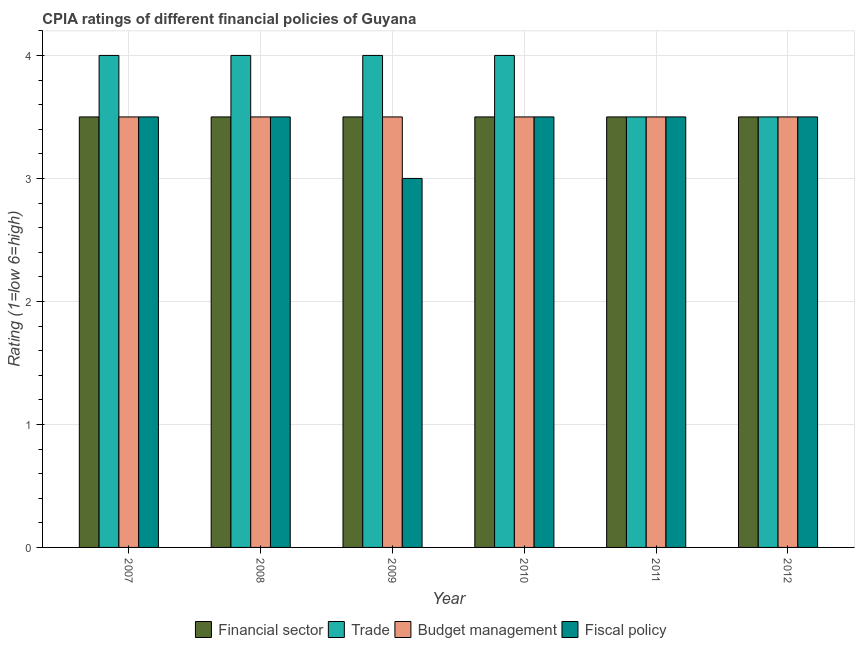How many different coloured bars are there?
Make the answer very short. 4. In how many cases, is the number of bars for a given year not equal to the number of legend labels?
Offer a very short reply. 0. What is the cpia rating of budget management in 2012?
Your response must be concise. 3.5. Across all years, what is the maximum cpia rating of budget management?
Provide a short and direct response. 3.5. In which year was the cpia rating of fiscal policy maximum?
Provide a short and direct response. 2007. In which year was the cpia rating of financial sector minimum?
Your response must be concise. 2007. What is the total cpia rating of financial sector in the graph?
Your answer should be compact. 21. What is the difference between the cpia rating of financial sector in 2008 and that in 2012?
Offer a very short reply. 0. What is the difference between the cpia rating of fiscal policy in 2012 and the cpia rating of budget management in 2007?
Provide a short and direct response. 0. In the year 2010, what is the difference between the cpia rating of fiscal policy and cpia rating of trade?
Keep it short and to the point. 0. In how many years, is the cpia rating of fiscal policy greater than 3.4?
Give a very brief answer. 5. Is the cpia rating of financial sector in 2010 less than that in 2011?
Make the answer very short. No. What is the difference between the highest and the second highest cpia rating of trade?
Make the answer very short. 0. What is the difference between the highest and the lowest cpia rating of trade?
Your answer should be very brief. 0.5. In how many years, is the cpia rating of trade greater than the average cpia rating of trade taken over all years?
Give a very brief answer. 4. What does the 4th bar from the left in 2012 represents?
Ensure brevity in your answer.  Fiscal policy. What does the 1st bar from the right in 2009 represents?
Offer a very short reply. Fiscal policy. Are all the bars in the graph horizontal?
Offer a very short reply. No. How many years are there in the graph?
Provide a short and direct response. 6. What is the difference between two consecutive major ticks on the Y-axis?
Keep it short and to the point. 1. Are the values on the major ticks of Y-axis written in scientific E-notation?
Your answer should be very brief. No. How are the legend labels stacked?
Keep it short and to the point. Horizontal. What is the title of the graph?
Offer a terse response. CPIA ratings of different financial policies of Guyana. What is the Rating (1=low 6=high) of Financial sector in 2007?
Give a very brief answer. 3.5. What is the Rating (1=low 6=high) of Budget management in 2007?
Give a very brief answer. 3.5. What is the Rating (1=low 6=high) in Fiscal policy in 2007?
Keep it short and to the point. 3.5. What is the Rating (1=low 6=high) of Financial sector in 2008?
Provide a short and direct response. 3.5. What is the Rating (1=low 6=high) of Trade in 2009?
Keep it short and to the point. 4. What is the Rating (1=low 6=high) in Budget management in 2009?
Your response must be concise. 3.5. What is the Rating (1=low 6=high) in Financial sector in 2010?
Offer a very short reply. 3.5. What is the Rating (1=low 6=high) of Trade in 2011?
Provide a succinct answer. 3.5. What is the Rating (1=low 6=high) in Fiscal policy in 2011?
Your response must be concise. 3.5. What is the Rating (1=low 6=high) in Trade in 2012?
Make the answer very short. 3.5. What is the Rating (1=low 6=high) of Fiscal policy in 2012?
Provide a succinct answer. 3.5. Across all years, what is the maximum Rating (1=low 6=high) of Financial sector?
Your response must be concise. 3.5. Across all years, what is the maximum Rating (1=low 6=high) of Trade?
Your answer should be compact. 4. Across all years, what is the maximum Rating (1=low 6=high) of Budget management?
Make the answer very short. 3.5. Across all years, what is the maximum Rating (1=low 6=high) of Fiscal policy?
Your answer should be very brief. 3.5. Across all years, what is the minimum Rating (1=low 6=high) of Financial sector?
Provide a succinct answer. 3.5. Across all years, what is the minimum Rating (1=low 6=high) in Budget management?
Your response must be concise. 3.5. Across all years, what is the minimum Rating (1=low 6=high) of Fiscal policy?
Offer a terse response. 3. What is the total Rating (1=low 6=high) of Financial sector in the graph?
Make the answer very short. 21. What is the total Rating (1=low 6=high) of Trade in the graph?
Offer a terse response. 23. What is the total Rating (1=low 6=high) of Budget management in the graph?
Provide a short and direct response. 21. What is the total Rating (1=low 6=high) in Fiscal policy in the graph?
Offer a very short reply. 20.5. What is the difference between the Rating (1=low 6=high) in Trade in 2007 and that in 2008?
Offer a terse response. 0. What is the difference between the Rating (1=low 6=high) in Fiscal policy in 2007 and that in 2009?
Your answer should be very brief. 0.5. What is the difference between the Rating (1=low 6=high) of Financial sector in 2007 and that in 2010?
Provide a succinct answer. 0. What is the difference between the Rating (1=low 6=high) of Financial sector in 2007 and that in 2011?
Ensure brevity in your answer.  0. What is the difference between the Rating (1=low 6=high) in Fiscal policy in 2007 and that in 2011?
Provide a short and direct response. 0. What is the difference between the Rating (1=low 6=high) in Financial sector in 2007 and that in 2012?
Your answer should be very brief. 0. What is the difference between the Rating (1=low 6=high) in Budget management in 2007 and that in 2012?
Provide a short and direct response. 0. What is the difference between the Rating (1=low 6=high) of Fiscal policy in 2007 and that in 2012?
Your answer should be compact. 0. What is the difference between the Rating (1=low 6=high) in Financial sector in 2008 and that in 2009?
Your response must be concise. 0. What is the difference between the Rating (1=low 6=high) in Budget management in 2008 and that in 2009?
Ensure brevity in your answer.  0. What is the difference between the Rating (1=low 6=high) in Financial sector in 2008 and that in 2010?
Offer a terse response. 0. What is the difference between the Rating (1=low 6=high) of Budget management in 2008 and that in 2010?
Your response must be concise. 0. What is the difference between the Rating (1=low 6=high) in Fiscal policy in 2008 and that in 2010?
Ensure brevity in your answer.  0. What is the difference between the Rating (1=low 6=high) in Financial sector in 2008 and that in 2011?
Your answer should be very brief. 0. What is the difference between the Rating (1=low 6=high) in Trade in 2008 and that in 2011?
Keep it short and to the point. 0.5. What is the difference between the Rating (1=low 6=high) of Financial sector in 2008 and that in 2012?
Your answer should be very brief. 0. What is the difference between the Rating (1=low 6=high) of Trade in 2008 and that in 2012?
Make the answer very short. 0.5. What is the difference between the Rating (1=low 6=high) of Fiscal policy in 2008 and that in 2012?
Offer a very short reply. 0. What is the difference between the Rating (1=low 6=high) of Trade in 2009 and that in 2010?
Offer a terse response. 0. What is the difference between the Rating (1=low 6=high) in Budget management in 2009 and that in 2010?
Make the answer very short. 0. What is the difference between the Rating (1=low 6=high) of Financial sector in 2009 and that in 2011?
Make the answer very short. 0. What is the difference between the Rating (1=low 6=high) of Trade in 2009 and that in 2011?
Give a very brief answer. 0.5. What is the difference between the Rating (1=low 6=high) of Budget management in 2009 and that in 2011?
Offer a very short reply. 0. What is the difference between the Rating (1=low 6=high) in Financial sector in 2009 and that in 2012?
Provide a succinct answer. 0. What is the difference between the Rating (1=low 6=high) in Budget management in 2010 and that in 2011?
Keep it short and to the point. 0. What is the difference between the Rating (1=low 6=high) in Fiscal policy in 2010 and that in 2011?
Give a very brief answer. 0. What is the difference between the Rating (1=low 6=high) of Budget management in 2010 and that in 2012?
Your answer should be compact. 0. What is the difference between the Rating (1=low 6=high) in Fiscal policy in 2010 and that in 2012?
Your answer should be compact. 0. What is the difference between the Rating (1=low 6=high) in Financial sector in 2011 and that in 2012?
Make the answer very short. 0. What is the difference between the Rating (1=low 6=high) of Budget management in 2011 and that in 2012?
Give a very brief answer. 0. What is the difference between the Rating (1=low 6=high) of Fiscal policy in 2011 and that in 2012?
Your answer should be very brief. 0. What is the difference between the Rating (1=low 6=high) of Financial sector in 2007 and the Rating (1=low 6=high) of Fiscal policy in 2008?
Offer a very short reply. 0. What is the difference between the Rating (1=low 6=high) of Trade in 2007 and the Rating (1=low 6=high) of Budget management in 2008?
Keep it short and to the point. 0.5. What is the difference between the Rating (1=low 6=high) in Trade in 2007 and the Rating (1=low 6=high) in Fiscal policy in 2008?
Offer a very short reply. 0.5. What is the difference between the Rating (1=low 6=high) in Budget management in 2007 and the Rating (1=low 6=high) in Fiscal policy in 2008?
Provide a short and direct response. 0. What is the difference between the Rating (1=low 6=high) in Trade in 2007 and the Rating (1=low 6=high) in Budget management in 2009?
Offer a terse response. 0.5. What is the difference between the Rating (1=low 6=high) in Financial sector in 2007 and the Rating (1=low 6=high) in Trade in 2010?
Provide a short and direct response. -0.5. What is the difference between the Rating (1=low 6=high) of Financial sector in 2007 and the Rating (1=low 6=high) of Budget management in 2010?
Ensure brevity in your answer.  0. What is the difference between the Rating (1=low 6=high) of Financial sector in 2007 and the Rating (1=low 6=high) of Fiscal policy in 2010?
Your answer should be very brief. 0. What is the difference between the Rating (1=low 6=high) of Trade in 2007 and the Rating (1=low 6=high) of Fiscal policy in 2010?
Your response must be concise. 0.5. What is the difference between the Rating (1=low 6=high) in Budget management in 2007 and the Rating (1=low 6=high) in Fiscal policy in 2010?
Make the answer very short. 0. What is the difference between the Rating (1=low 6=high) of Financial sector in 2007 and the Rating (1=low 6=high) of Fiscal policy in 2011?
Make the answer very short. 0. What is the difference between the Rating (1=low 6=high) in Trade in 2007 and the Rating (1=low 6=high) in Budget management in 2011?
Offer a very short reply. 0.5. What is the difference between the Rating (1=low 6=high) in Trade in 2007 and the Rating (1=low 6=high) in Fiscal policy in 2011?
Offer a very short reply. 0.5. What is the difference between the Rating (1=low 6=high) in Budget management in 2007 and the Rating (1=low 6=high) in Fiscal policy in 2011?
Your answer should be compact. 0. What is the difference between the Rating (1=low 6=high) of Trade in 2007 and the Rating (1=low 6=high) of Budget management in 2012?
Provide a short and direct response. 0.5. What is the difference between the Rating (1=low 6=high) in Trade in 2007 and the Rating (1=low 6=high) in Fiscal policy in 2012?
Your answer should be compact. 0.5. What is the difference between the Rating (1=low 6=high) of Budget management in 2007 and the Rating (1=low 6=high) of Fiscal policy in 2012?
Your response must be concise. 0. What is the difference between the Rating (1=low 6=high) of Financial sector in 2008 and the Rating (1=low 6=high) of Budget management in 2009?
Provide a short and direct response. 0. What is the difference between the Rating (1=low 6=high) of Financial sector in 2008 and the Rating (1=low 6=high) of Trade in 2010?
Ensure brevity in your answer.  -0.5. What is the difference between the Rating (1=low 6=high) of Financial sector in 2008 and the Rating (1=low 6=high) of Budget management in 2010?
Your answer should be very brief. 0. What is the difference between the Rating (1=low 6=high) in Financial sector in 2008 and the Rating (1=low 6=high) in Fiscal policy in 2010?
Provide a short and direct response. 0. What is the difference between the Rating (1=low 6=high) in Trade in 2008 and the Rating (1=low 6=high) in Budget management in 2010?
Your response must be concise. 0.5. What is the difference between the Rating (1=low 6=high) in Financial sector in 2008 and the Rating (1=low 6=high) in Fiscal policy in 2011?
Your answer should be compact. 0. What is the difference between the Rating (1=low 6=high) of Financial sector in 2008 and the Rating (1=low 6=high) of Trade in 2012?
Your answer should be very brief. 0. What is the difference between the Rating (1=low 6=high) of Trade in 2008 and the Rating (1=low 6=high) of Budget management in 2012?
Offer a very short reply. 0.5. What is the difference between the Rating (1=low 6=high) of Budget management in 2008 and the Rating (1=low 6=high) of Fiscal policy in 2012?
Provide a short and direct response. 0. What is the difference between the Rating (1=low 6=high) of Financial sector in 2009 and the Rating (1=low 6=high) of Budget management in 2010?
Your answer should be very brief. 0. What is the difference between the Rating (1=low 6=high) in Financial sector in 2009 and the Rating (1=low 6=high) in Fiscal policy in 2010?
Offer a very short reply. 0. What is the difference between the Rating (1=low 6=high) in Trade in 2009 and the Rating (1=low 6=high) in Budget management in 2010?
Offer a very short reply. 0.5. What is the difference between the Rating (1=low 6=high) of Financial sector in 2009 and the Rating (1=low 6=high) of Trade in 2011?
Your answer should be compact. 0. What is the difference between the Rating (1=low 6=high) in Trade in 2009 and the Rating (1=low 6=high) in Fiscal policy in 2011?
Offer a very short reply. 0.5. What is the difference between the Rating (1=low 6=high) in Financial sector in 2009 and the Rating (1=low 6=high) in Trade in 2012?
Ensure brevity in your answer.  0. What is the difference between the Rating (1=low 6=high) of Financial sector in 2009 and the Rating (1=low 6=high) of Fiscal policy in 2012?
Offer a very short reply. 0. What is the difference between the Rating (1=low 6=high) of Trade in 2009 and the Rating (1=low 6=high) of Budget management in 2012?
Provide a short and direct response. 0.5. What is the difference between the Rating (1=low 6=high) of Trade in 2009 and the Rating (1=low 6=high) of Fiscal policy in 2012?
Offer a very short reply. 0.5. What is the difference between the Rating (1=low 6=high) in Budget management in 2009 and the Rating (1=low 6=high) in Fiscal policy in 2012?
Keep it short and to the point. 0. What is the difference between the Rating (1=low 6=high) of Financial sector in 2010 and the Rating (1=low 6=high) of Trade in 2011?
Give a very brief answer. 0. What is the difference between the Rating (1=low 6=high) in Trade in 2010 and the Rating (1=low 6=high) in Budget management in 2011?
Your answer should be compact. 0.5. What is the difference between the Rating (1=low 6=high) in Budget management in 2010 and the Rating (1=low 6=high) in Fiscal policy in 2011?
Keep it short and to the point. 0. What is the difference between the Rating (1=low 6=high) of Financial sector in 2010 and the Rating (1=low 6=high) of Trade in 2012?
Give a very brief answer. 0. What is the difference between the Rating (1=low 6=high) of Financial sector in 2010 and the Rating (1=low 6=high) of Fiscal policy in 2012?
Your answer should be compact. 0. What is the difference between the Rating (1=low 6=high) of Trade in 2010 and the Rating (1=low 6=high) of Budget management in 2012?
Make the answer very short. 0.5. What is the difference between the Rating (1=low 6=high) in Budget management in 2010 and the Rating (1=low 6=high) in Fiscal policy in 2012?
Your response must be concise. 0. What is the difference between the Rating (1=low 6=high) in Trade in 2011 and the Rating (1=low 6=high) in Fiscal policy in 2012?
Give a very brief answer. 0. What is the difference between the Rating (1=low 6=high) of Budget management in 2011 and the Rating (1=low 6=high) of Fiscal policy in 2012?
Make the answer very short. 0. What is the average Rating (1=low 6=high) of Trade per year?
Provide a succinct answer. 3.83. What is the average Rating (1=low 6=high) of Budget management per year?
Your answer should be compact. 3.5. What is the average Rating (1=low 6=high) of Fiscal policy per year?
Keep it short and to the point. 3.42. In the year 2007, what is the difference between the Rating (1=low 6=high) in Financial sector and Rating (1=low 6=high) in Budget management?
Your answer should be compact. 0. In the year 2007, what is the difference between the Rating (1=low 6=high) of Trade and Rating (1=low 6=high) of Budget management?
Give a very brief answer. 0.5. In the year 2007, what is the difference between the Rating (1=low 6=high) of Budget management and Rating (1=low 6=high) of Fiscal policy?
Keep it short and to the point. 0. In the year 2008, what is the difference between the Rating (1=low 6=high) in Financial sector and Rating (1=low 6=high) in Budget management?
Give a very brief answer. 0. In the year 2008, what is the difference between the Rating (1=low 6=high) of Budget management and Rating (1=low 6=high) of Fiscal policy?
Offer a very short reply. 0. In the year 2009, what is the difference between the Rating (1=low 6=high) in Trade and Rating (1=low 6=high) in Budget management?
Provide a succinct answer. 0.5. In the year 2009, what is the difference between the Rating (1=low 6=high) of Trade and Rating (1=low 6=high) of Fiscal policy?
Your answer should be compact. 1. In the year 2009, what is the difference between the Rating (1=low 6=high) of Budget management and Rating (1=low 6=high) of Fiscal policy?
Your answer should be very brief. 0.5. In the year 2010, what is the difference between the Rating (1=low 6=high) in Financial sector and Rating (1=low 6=high) in Trade?
Provide a succinct answer. -0.5. In the year 2010, what is the difference between the Rating (1=low 6=high) in Financial sector and Rating (1=low 6=high) in Budget management?
Provide a short and direct response. 0. In the year 2010, what is the difference between the Rating (1=low 6=high) in Trade and Rating (1=low 6=high) in Budget management?
Your response must be concise. 0.5. In the year 2011, what is the difference between the Rating (1=low 6=high) of Financial sector and Rating (1=low 6=high) of Trade?
Provide a succinct answer. 0. In the year 2011, what is the difference between the Rating (1=low 6=high) in Financial sector and Rating (1=low 6=high) in Budget management?
Your response must be concise. 0. In the year 2012, what is the difference between the Rating (1=low 6=high) in Financial sector and Rating (1=low 6=high) in Budget management?
Your answer should be very brief. 0. In the year 2012, what is the difference between the Rating (1=low 6=high) in Financial sector and Rating (1=low 6=high) in Fiscal policy?
Keep it short and to the point. 0. In the year 2012, what is the difference between the Rating (1=low 6=high) in Trade and Rating (1=low 6=high) in Fiscal policy?
Keep it short and to the point. 0. What is the ratio of the Rating (1=low 6=high) of Financial sector in 2007 to that in 2008?
Offer a very short reply. 1. What is the ratio of the Rating (1=low 6=high) in Trade in 2007 to that in 2008?
Offer a terse response. 1. What is the ratio of the Rating (1=low 6=high) in Budget management in 2007 to that in 2008?
Your answer should be compact. 1. What is the ratio of the Rating (1=low 6=high) in Budget management in 2007 to that in 2009?
Make the answer very short. 1. What is the ratio of the Rating (1=low 6=high) in Fiscal policy in 2007 to that in 2009?
Provide a succinct answer. 1.17. What is the ratio of the Rating (1=low 6=high) of Financial sector in 2007 to that in 2010?
Your response must be concise. 1. What is the ratio of the Rating (1=low 6=high) of Fiscal policy in 2007 to that in 2010?
Offer a terse response. 1. What is the ratio of the Rating (1=low 6=high) of Financial sector in 2007 to that in 2011?
Provide a succinct answer. 1. What is the ratio of the Rating (1=low 6=high) in Budget management in 2007 to that in 2011?
Your response must be concise. 1. What is the ratio of the Rating (1=low 6=high) of Budget management in 2008 to that in 2009?
Give a very brief answer. 1. What is the ratio of the Rating (1=low 6=high) in Fiscal policy in 2008 to that in 2009?
Make the answer very short. 1.17. What is the ratio of the Rating (1=low 6=high) of Fiscal policy in 2008 to that in 2010?
Your answer should be very brief. 1. What is the ratio of the Rating (1=low 6=high) in Trade in 2008 to that in 2011?
Offer a terse response. 1.14. What is the ratio of the Rating (1=low 6=high) of Fiscal policy in 2008 to that in 2011?
Your response must be concise. 1. What is the ratio of the Rating (1=low 6=high) of Trade in 2008 to that in 2012?
Offer a terse response. 1.14. What is the ratio of the Rating (1=low 6=high) in Budget management in 2008 to that in 2012?
Provide a succinct answer. 1. What is the ratio of the Rating (1=low 6=high) in Fiscal policy in 2008 to that in 2012?
Offer a terse response. 1. What is the ratio of the Rating (1=low 6=high) in Financial sector in 2009 to that in 2010?
Offer a terse response. 1. What is the ratio of the Rating (1=low 6=high) in Budget management in 2009 to that in 2011?
Offer a terse response. 1. What is the ratio of the Rating (1=low 6=high) in Financial sector in 2009 to that in 2012?
Give a very brief answer. 1. What is the ratio of the Rating (1=low 6=high) in Budget management in 2009 to that in 2012?
Provide a succinct answer. 1. What is the ratio of the Rating (1=low 6=high) of Fiscal policy in 2009 to that in 2012?
Offer a very short reply. 0.86. What is the ratio of the Rating (1=low 6=high) of Trade in 2010 to that in 2011?
Ensure brevity in your answer.  1.14. What is the ratio of the Rating (1=low 6=high) in Fiscal policy in 2010 to that in 2011?
Make the answer very short. 1. What is the ratio of the Rating (1=low 6=high) in Financial sector in 2010 to that in 2012?
Offer a very short reply. 1. What is the ratio of the Rating (1=low 6=high) of Fiscal policy in 2010 to that in 2012?
Offer a very short reply. 1. What is the ratio of the Rating (1=low 6=high) of Financial sector in 2011 to that in 2012?
Give a very brief answer. 1. What is the ratio of the Rating (1=low 6=high) in Trade in 2011 to that in 2012?
Your response must be concise. 1. What is the ratio of the Rating (1=low 6=high) of Fiscal policy in 2011 to that in 2012?
Keep it short and to the point. 1. What is the difference between the highest and the second highest Rating (1=low 6=high) of Financial sector?
Make the answer very short. 0. What is the difference between the highest and the second highest Rating (1=low 6=high) in Trade?
Provide a short and direct response. 0. What is the difference between the highest and the second highest Rating (1=low 6=high) of Budget management?
Ensure brevity in your answer.  0. What is the difference between the highest and the second highest Rating (1=low 6=high) in Fiscal policy?
Ensure brevity in your answer.  0. What is the difference between the highest and the lowest Rating (1=low 6=high) in Trade?
Give a very brief answer. 0.5. What is the difference between the highest and the lowest Rating (1=low 6=high) of Budget management?
Provide a short and direct response. 0. 